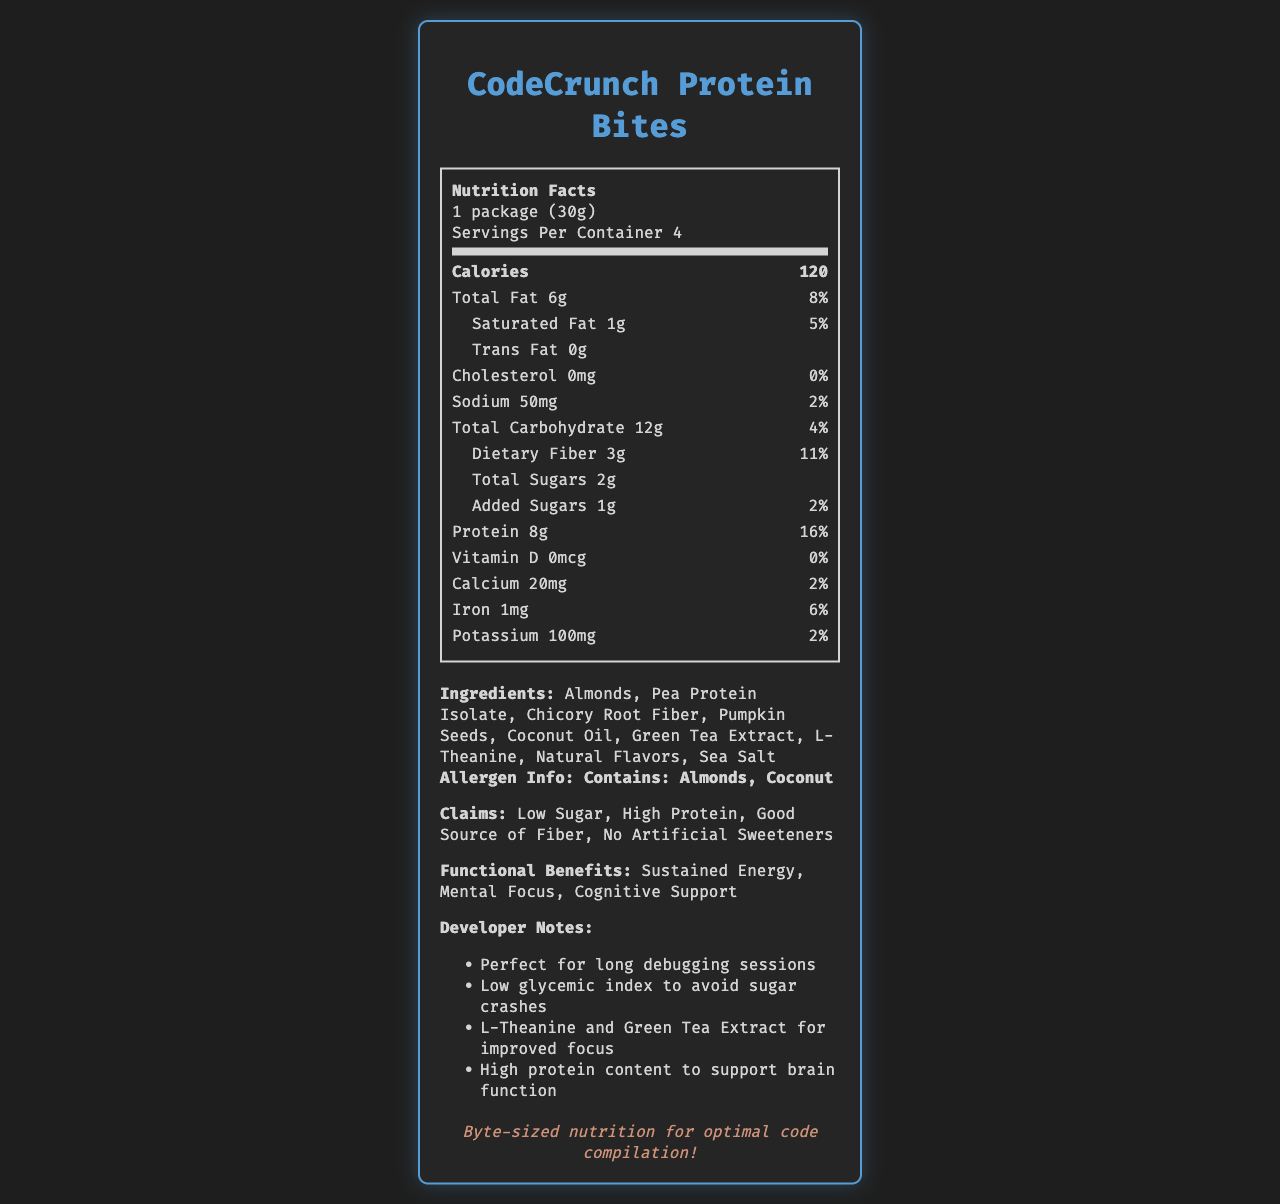how many servings are there per container? The document indicates that there are 4 servings per container.
Answer: 4 what is the serving size of CodeCrunch Protein Bites? The serving size listed in the document is 1 package (30g).
Answer: 1 package (30g) how many grams of protein does each serving contain? The document mentions that each serving contains 8g of protein.
Answer: 8g what are the two ingredients with explicit allergen information? The allergen information specifies that the product contains almonds and coconut.
Answer: Almonds, Coconut how much total fat is there per serving and its percent daily value? The document lists total fat as 6g per serving and it constitutes 8% of the daily value.
Answer: 6g, 8% which of these ingredients is not listed in the document? A. Pea Protein Isolate B. Chicory Root Fiber C. Wheat Germ D. Green Tea Extract Wheat Germ is not listed among the ingredients in the document.
Answer: C what benefit is associated with L-Theanine and Green Tea Extract in the developer notes? A. High protein content B. Mental Focus C. Low sugar D. Good source of fiber L-Theanine and Green Tea Extract are stated to improve Mental Focus.
Answer: B is there any cholesterol in CodeCrunch Protein Bites? The document indicates that the cholesterol amount is 0mg, meaning there is no cholesterol.
Answer: No summarize the main claims and benefits of CodeCrunch Protein Bites. The product is marketed as having low sugar, high protein, and being a good source of fiber with no artificial sweeteners. Additionally, it offers benefits like sustained energy, mental focus, and cognitive support.
Answer: Low Sugar, High Protein, Good Source of Fiber, No Artificial Sweeteners; Sustained Energy, Mental Focus, Cognitive Support what is the percentage daily value of dietary fiber? The document shows that dietary fiber constitutes 11% of the daily value per serving.
Answer: 11% how much calcium is present per serving? The document states each serving contains 20mg of calcium.
Answer: 20mg what are the calories per serving? A. 80 B. 100 C. 120 D. 140 The calorie count per serving is 120 as indicated in the document.
Answer: C is total sugar content higher than the added sugars content? The total sugars are 2g, whereas the added sugars are 1g, which means total sugars are higher.
Answer: Yes what is the main focus in the developer notes about the function of the product? The developer notes emphasize the product’s benefits for mental focus and sustained energy, particularly useful during long debugging sessions.
Answer: Mental Focus and Energy for long debugging sessions what is the glycemic index of CodeCrunch Protein Bites? The document does not provide information about the glycemic index of the product.
Answer: Cannot be determined 